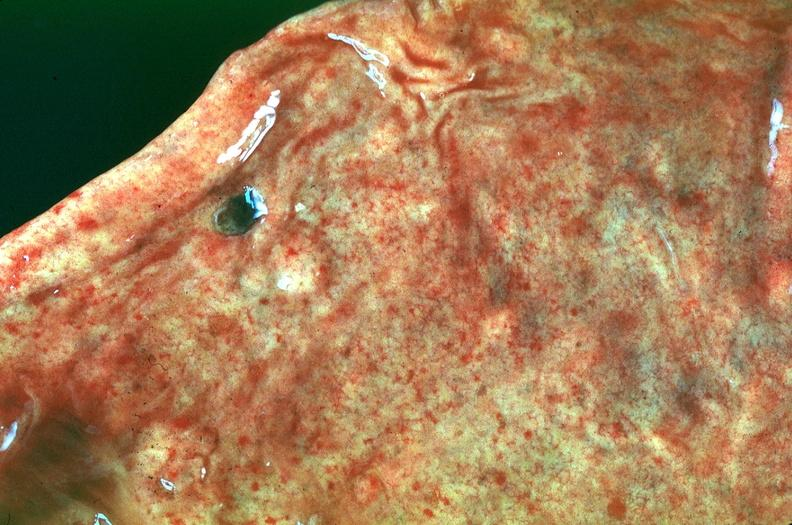does nodule show stomach, petechial hemorrhages in a patient with disseminated intravascular coagulation and alpha-1 antitrypsin deficiency?
Answer the question using a single word or phrase. No 